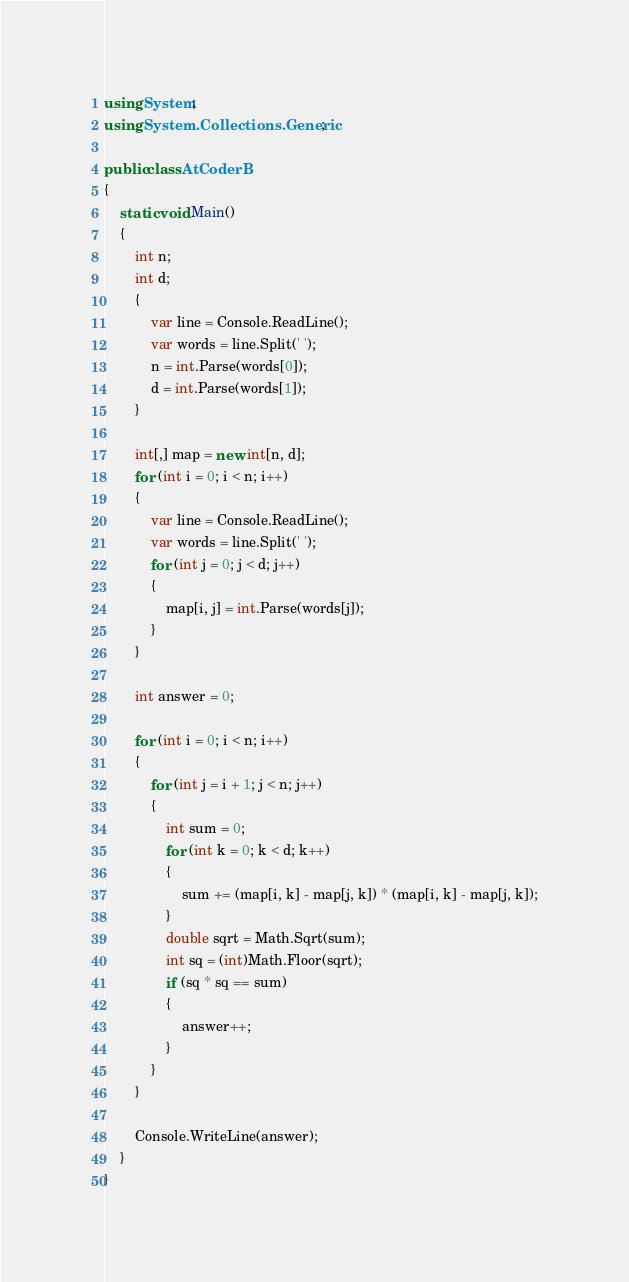<code> <loc_0><loc_0><loc_500><loc_500><_C#_>using System;
using System.Collections.Generic;

public class AtCoderB
{
    static void Main()
    {
        int n;
        int d;
        {
            var line = Console.ReadLine();
            var words = line.Split(' ');
            n = int.Parse(words[0]);
            d = int.Parse(words[1]);
        }

        int[,] map = new int[n, d];
        for (int i = 0; i < n; i++)
        {
            var line = Console.ReadLine();
            var words = line.Split(' ');
            for (int j = 0; j < d; j++)
            {
                map[i, j] = int.Parse(words[j]);
            }
        }

        int answer = 0;

        for (int i = 0; i < n; i++)
        {
            for (int j = i + 1; j < n; j++)
            {
                int sum = 0;
                for (int k = 0; k < d; k++)
                {
                    sum += (map[i, k] - map[j, k]) * (map[i, k] - map[j, k]);
                }
                double sqrt = Math.Sqrt(sum);
                int sq = (int)Math.Floor(sqrt);
                if (sq * sq == sum)
                {
                    answer++;
                }
            }
        }

        Console.WriteLine(answer);
    }
}</code> 